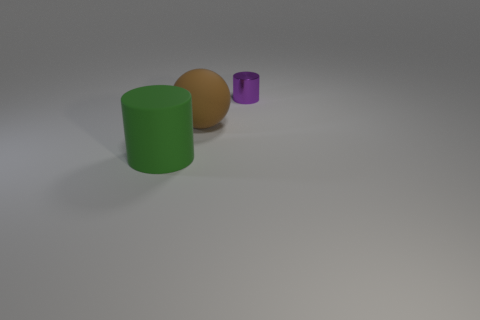Do the large rubber object that is right of the green rubber cylinder and the purple object have the same shape?
Offer a terse response. No. What is the color of the small metallic thing that is the same shape as the large green matte thing?
Provide a short and direct response. Purple. What size is the green thing that is the same shape as the purple shiny object?
Your response must be concise. Large. Are there an equal number of big things to the right of the tiny metal cylinder and big cyan rubber cubes?
Provide a succinct answer. Yes. Do the small shiny cylinder and the big matte cylinder have the same color?
Your answer should be very brief. No. What color is the thing that is left of the tiny thing and to the right of the big cylinder?
Ensure brevity in your answer.  Brown. How many spheres are brown rubber objects or tiny objects?
Give a very brief answer. 1. Are there fewer big green things on the left side of the large green rubber cylinder than small shiny things?
Your response must be concise. Yes. The green thing that is made of the same material as the big brown sphere is what shape?
Offer a very short reply. Cylinder. How many tiny objects are the same color as the big cylinder?
Your answer should be compact. 0. 